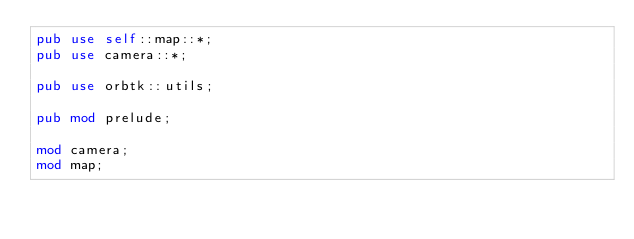Convert code to text. <code><loc_0><loc_0><loc_500><loc_500><_Rust_>pub use self::map::*;
pub use camera::*;

pub use orbtk::utils;

pub mod prelude;

mod camera;
mod map;
</code> 